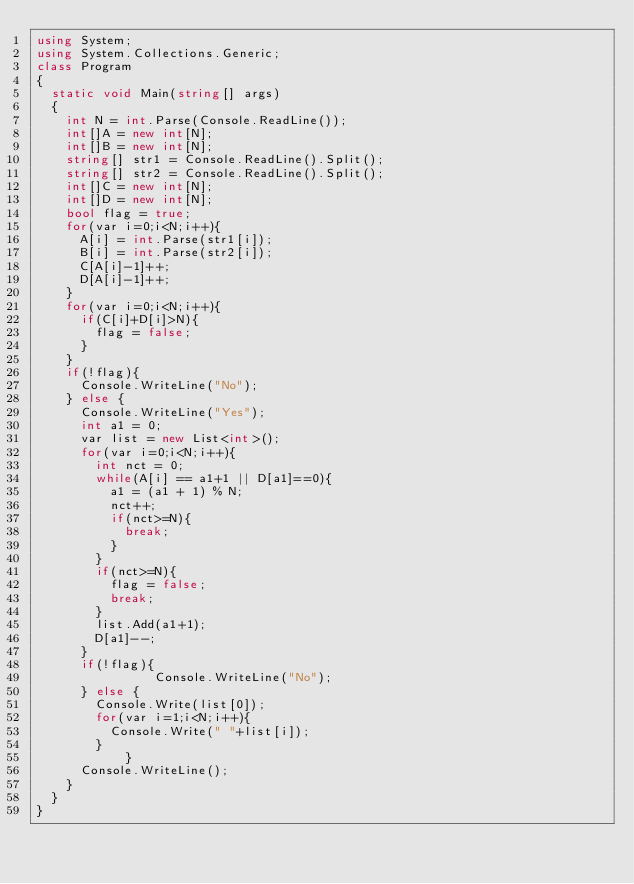<code> <loc_0><loc_0><loc_500><loc_500><_C#_>using System;
using System.Collections.Generic;
class Program
{
	static void Main(string[] args)
	{
		int N = int.Parse(Console.ReadLine());
		int[]A = new int[N];
		int[]B = new int[N];
		string[] str1 = Console.ReadLine().Split();
		string[] str2 = Console.ReadLine().Split();
		int[]C = new int[N];
		int[]D = new int[N];
		bool flag = true;
		for(var i=0;i<N;i++){
			A[i] = int.Parse(str1[i]);
			B[i] = int.Parse(str2[i]);
			C[A[i]-1]++;
			D[A[i]-1]++;
		}
		for(var i=0;i<N;i++){
			if(C[i]+D[i]>N){
				flag = false;
			}
		}
		if(!flag){
			Console.WriteLine("No");
		} else {
			Console.WriteLine("Yes");
			int a1 = 0;
			var list = new List<int>();
			for(var i=0;i<N;i++){
				int nct = 0;
				while(A[i] == a1+1 || D[a1]==0){
					a1 = (a1 + 1) % N;
					nct++;
					if(nct>=N){
						break;
					}
				}
				if(nct>=N){
					flag = false;
					break;
				}
				list.Add(a1+1);
				D[a1]--;
			}
			if(!flag){
              	Console.WriteLine("No");
			} else {
				Console.Write(list[0]);
				for(var i=1;i<N;i++){
					Console.Write(" "+list[i]);
				}
            }
			Console.WriteLine();
		}
	}
}</code> 